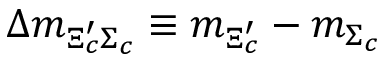Convert formula to latex. <formula><loc_0><loc_0><loc_500><loc_500>\Delta m _ { \Xi _ { c } ^ { \prime } \Sigma _ { c } } \equiv m _ { \Xi _ { c } ^ { \prime } } - m _ { \Sigma _ { c } }</formula> 